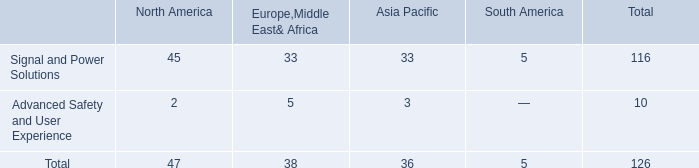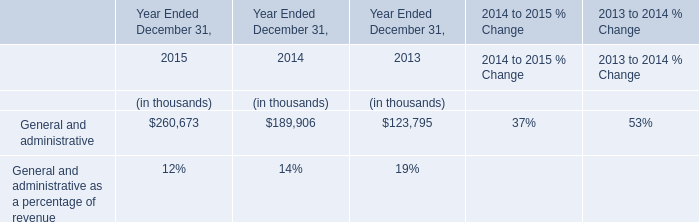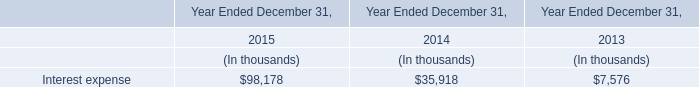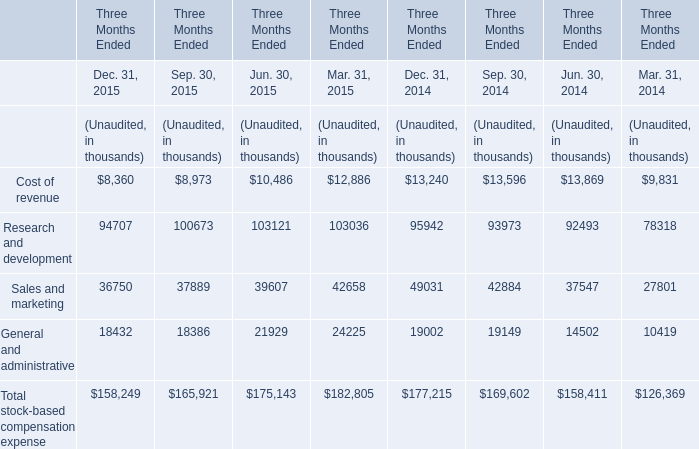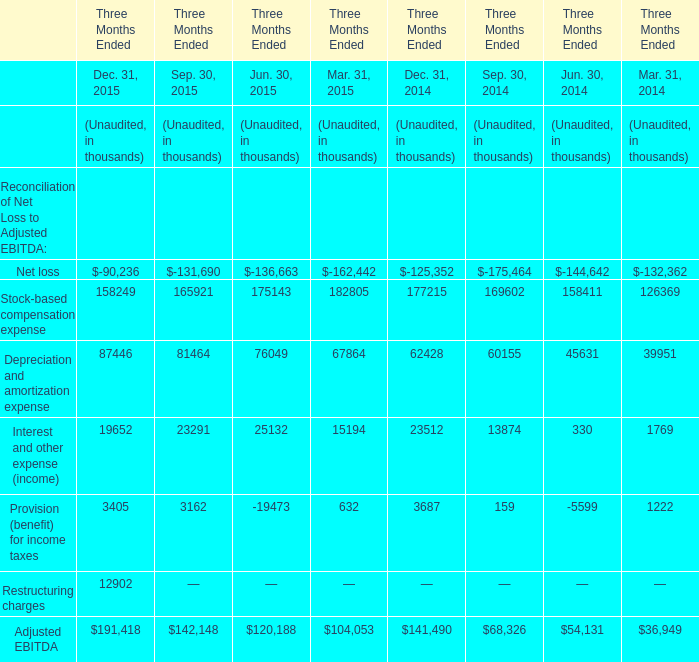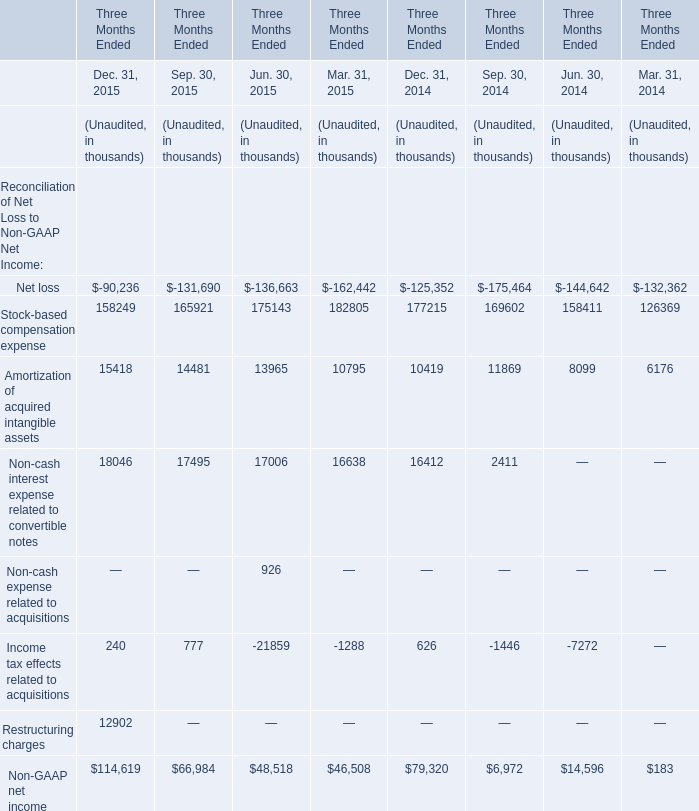In the year with largest amount of Dec. 31, 2015, what's the increasing rate of Interest and other expense (income)? (in %) 
Computations: ((19652 - 23291) / 23291)
Answer: -0.15624. 